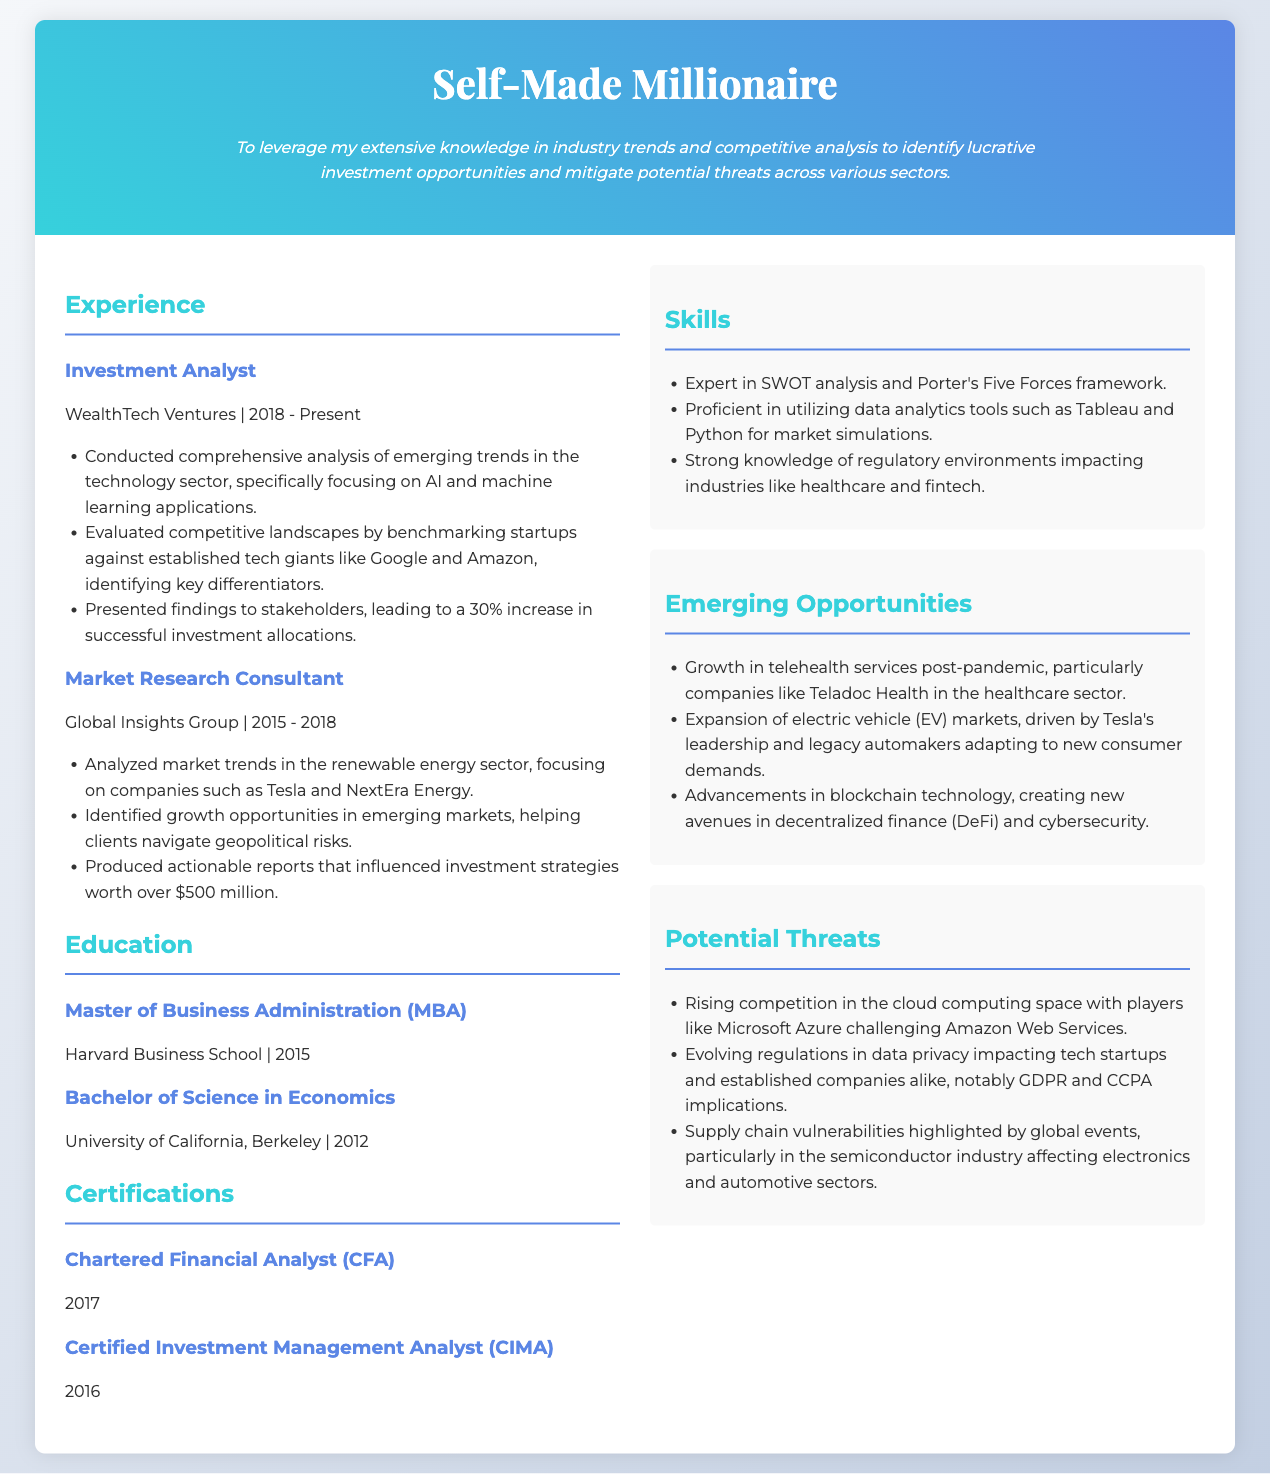what is the current position held by the individual? The individual currently holds the position of Investment Analyst at WealthTech Ventures.
Answer: Investment Analyst which certification was obtained in 2017? The document states that the Chartered Financial Analyst certification was obtained in 2017.
Answer: Chartered Financial Analyst how many years of experience in the industry does the individual have as of 2023? The individual has experience from 2015 to present (2023) with a total of 8 years in roles stated.
Answer: 8 years what is the name of the college where the individual completed their MBA? The document indicates that the individual completed their MBA at Harvard Business School.
Answer: Harvard Business School which emerging opportunity in the healthcare sector is mentioned? The document highlights the growth in telehealth services post-pandemic, particularly companies like Teladoc Health.
Answer: telehealth services what significant financial influence did the Market Research Consultant role have? The document notes that produced reports influenced investment strategies worth over $500 million.
Answer: $500 million name one potential threat in the cloud computing space. The document mentions rising competition in the cloud computing space as a potential threat.
Answer: rising competition what year did the individual graduate with a Bachelor of Science in Economics? The document states the individual graduated in 2012 with a Bachelor of Science in Economics.
Answer: 2012 which technology application is emphasized in the individual's current role? The analysis emphasizes AI and machine learning applications in the technology sector.
Answer: AI and machine learning applications 